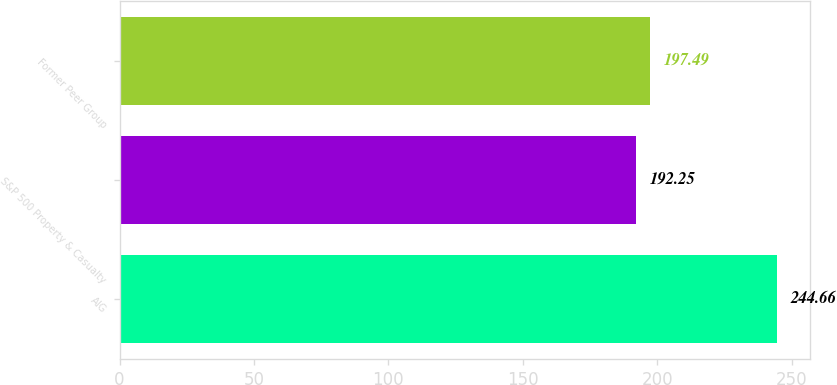<chart> <loc_0><loc_0><loc_500><loc_500><bar_chart><fcel>AIG<fcel>S&P 500 Property & Casualty<fcel>Former Peer Group<nl><fcel>244.66<fcel>192.25<fcel>197.49<nl></chart> 